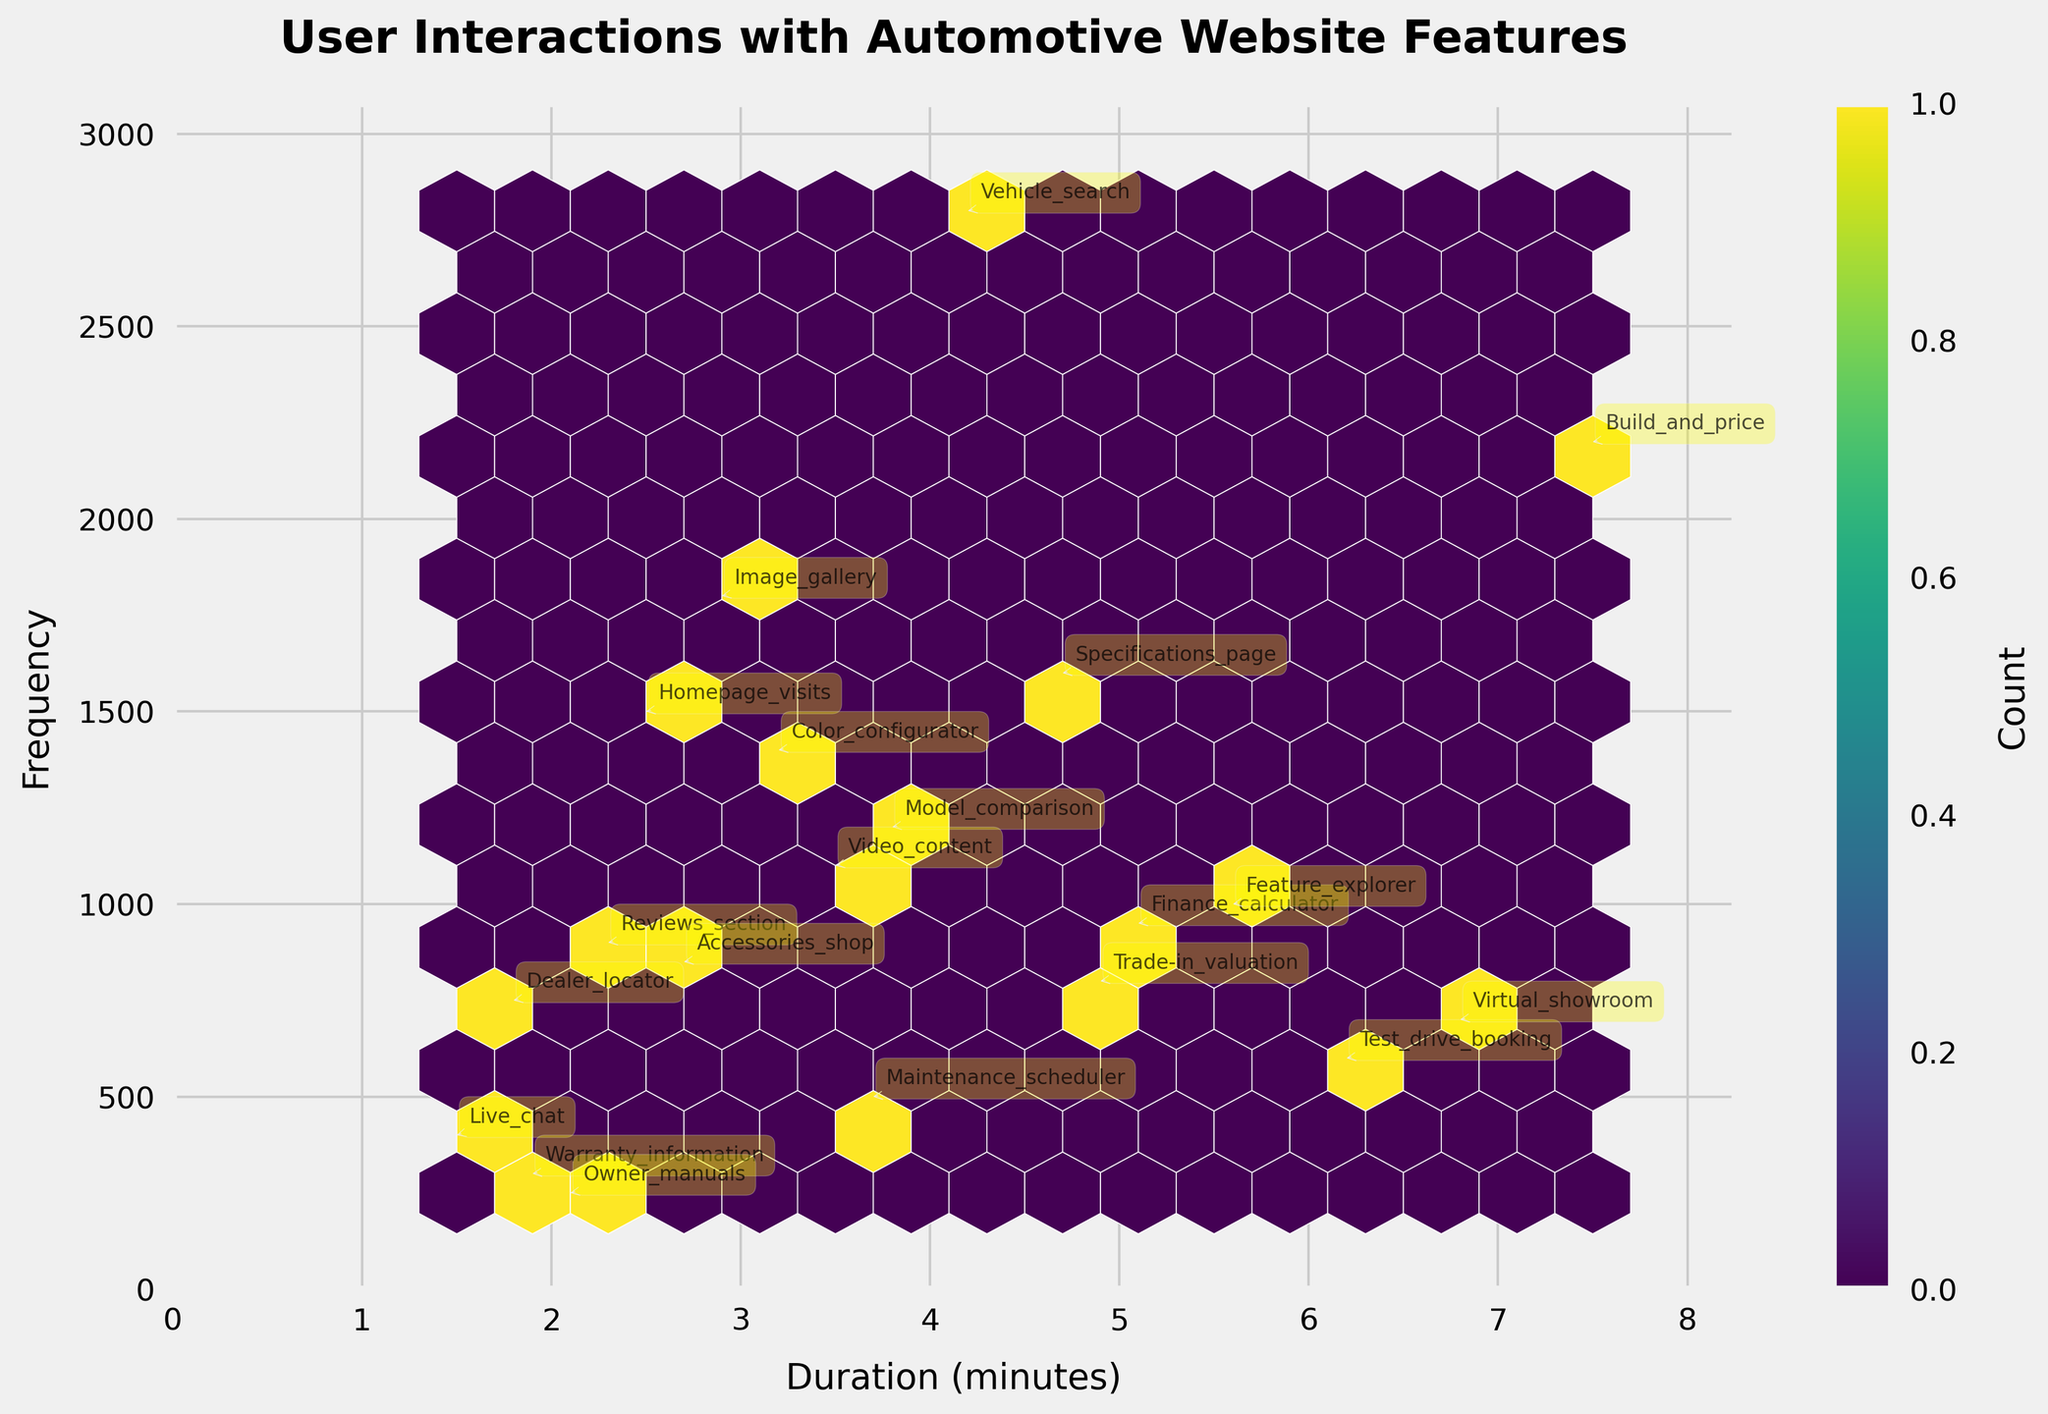What's the title of the plot? The title is often located at the top of the figure. In this plot, it is displayed prominently.
Answer: User Interactions with Automotive Website Features What are the labels of the x and y axes? The axis labels are positioned next to the axes in the plot. The x-axis label is 'Duration (minutes)', and the y-axis label is 'Frequency'.
Answer: Duration (minutes) and Frequency Which feature has the highest interaction frequency? To determine the feature with the highest interaction frequency, find the hexagons with the highest y-value and refer to the annotations nearby.
Answer: Vehicle_search Which feature has the longest duration of interaction? The longest duration corresponds to the highest x-value in the plot, and we can identify the feature from the label near this hexagon.
Answer: Build_and_price How many features have an interaction duration above 5 minutes? Count the number of hexagons to the right of the 5-minute mark on the x-axis. Identify the features based on their labels.
Answer: Five features Which feature has the lowest frequency of interaction? To find the feature with the lowest frequency, locate the hexagon with the lowest y-value and read the corresponding label.
Answer: Owner_manuals Compare the interaction frequency between 'Homepage_visits' and 'Live_chat'. Which one is higher? Find the y-values of the 'Homepage_visits' and 'Live_chat' hexagons and compare them. The frequency for 'Homepage_visits' (2.5) is greater than that for 'Live_chat' (1.5).
Answer: Homepage_visits What is the average duration of 'Finance_calculator' and 'Video_content'? Find the x-values for both 'Finance_calculator' and 'Video_content', sum them up and divide by 2 to get the average. (5.1 + 3.5) / 2 = 4.3
Answer: 4.3 minutes How many hexagons are there in total? Count all individual hexagons that appear in the plot. There are 20 points corresponding to 20 features.
Answer: 20 hexagons Which feature has a higher interaction count: 'Color_configurator' or 'Model_comparison'? Compare the y-values for the 'Color_configurator' and 'Model_comparison' hexagons. 'Model_comparison' has a frequency of 1200, while 'Color_configurator' has 1400.
Answer: Color_configurator 